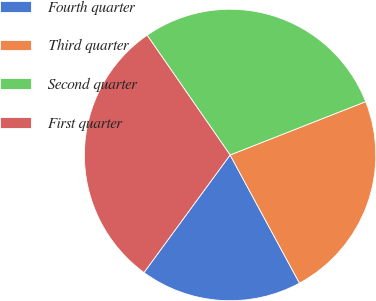Convert chart. <chart><loc_0><loc_0><loc_500><loc_500><pie_chart><fcel>Fourth quarter<fcel>Third quarter<fcel>Second quarter<fcel>First quarter<nl><fcel>17.96%<fcel>23.07%<fcel>28.68%<fcel>30.29%<nl></chart> 